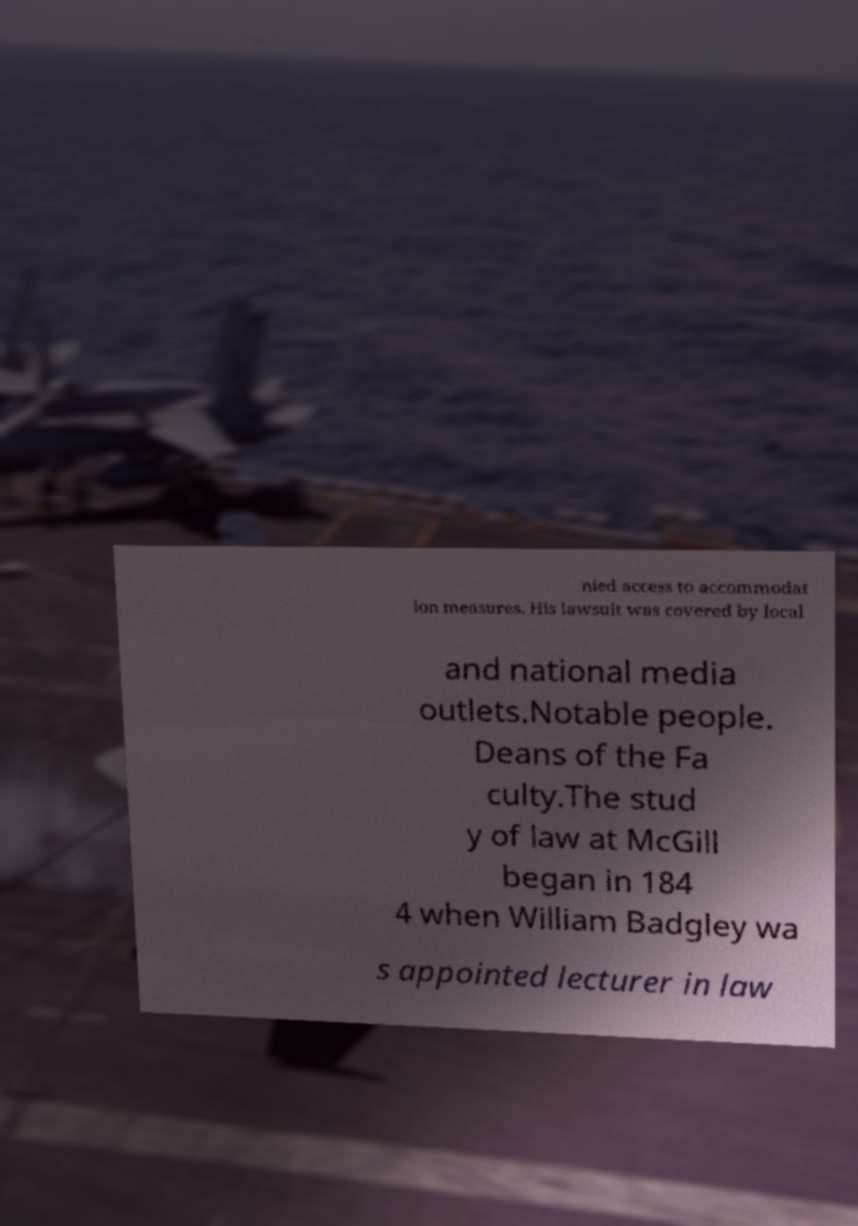What messages or text are displayed in this image? I need them in a readable, typed format. nied access to accommodat ion measures. His lawsuit was covered by local and national media outlets.Notable people. Deans of the Fa culty.The stud y of law at McGill began in 184 4 when William Badgley wa s appointed lecturer in law 